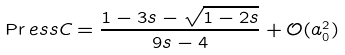<formula> <loc_0><loc_0><loc_500><loc_500>\Pr e s s C = \frac { 1 - 3 s - \sqrt { 1 - 2 s } } { 9 s - 4 } + \mathcal { O } ( a ^ { 2 } _ { 0 } )</formula> 